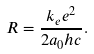Convert formula to latex. <formula><loc_0><loc_0><loc_500><loc_500>R = { \frac { k _ { e } e ^ { 2 } } { 2 a _ { 0 } h c } } .</formula> 